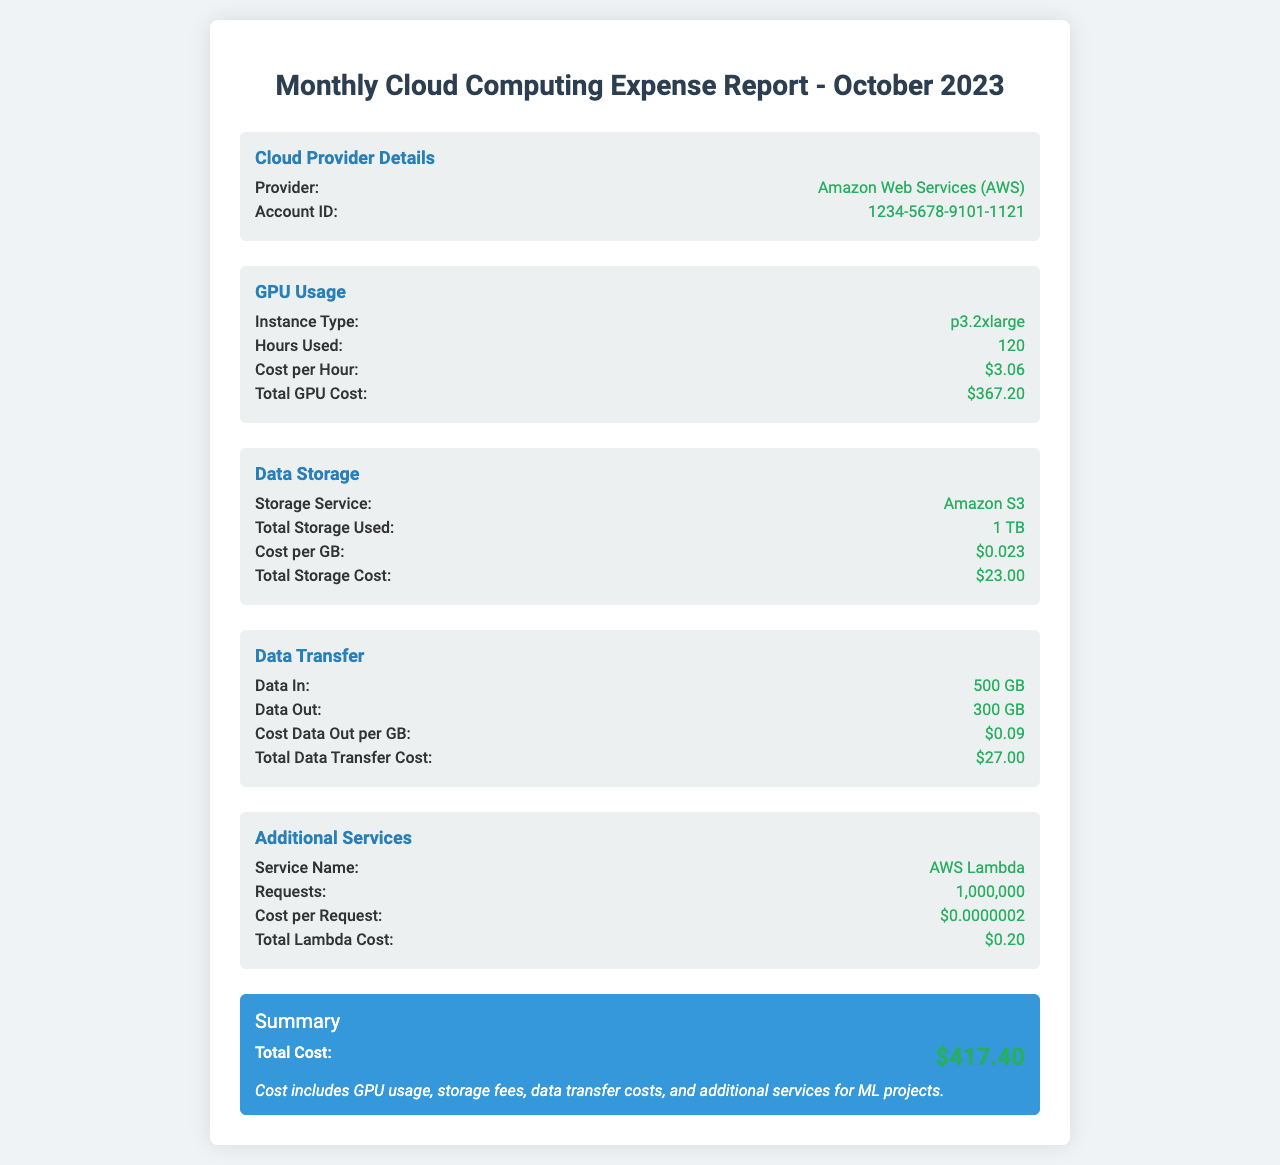What is the cloud provider? The document specifies the cloud provider being used for the computing resources, which is Amazon Web Services.
Answer: Amazon Web Services (AWS) How many hours were the GPUs used? The report states the total hours of GPU usage recorded for the month, which is 120.
Answer: 120 What is the total cost for GPU usage? The total cost for using the GPU resource is listed in the document, calculated as hours used multiplied by cost per hour.
Answer: $367.20 What is the storage cost per GB? The document provides the cost associated with data storage, which is specified as cost per GB for Amazon S3 service.
Answer: $0.023 What is the total data transfer cost? The summary in the report lists the total cost associated with data transfer for the month, which covers both incoming and outgoing data transfers.
Answer: $27.00 What service is mentioned for additional costs? The report lists an additional service utilized during the month beyond the primary GPU and storage costs, which is AWS Lambda.
Answer: AWS Lambda How many requests were made for the additional service? The document specifies the total number of requests made for additional services like Lambda during the reporting period.
Answer: 1,000,000 What is the total monthly expense reported? The summary at the end of the document consolidates all expenses into a total cost figure for easier reference.
Answer: $417.40 What type of GPU instance was used? The specific GPU instance type utilized in the machine learning project is detailed within the GPU usage section of the report.
Answer: p3.2xlarge 